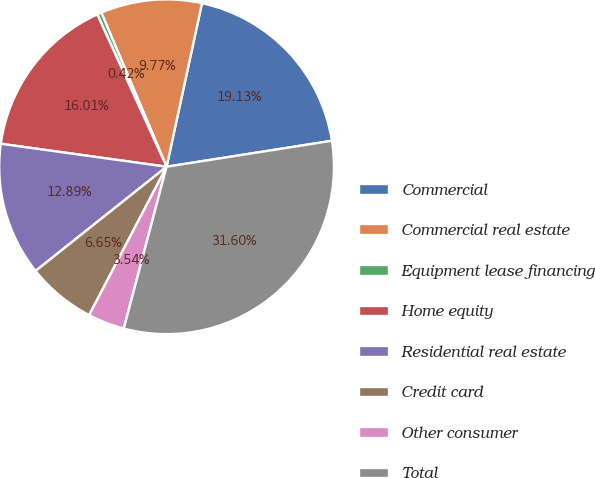Convert chart to OTSL. <chart><loc_0><loc_0><loc_500><loc_500><pie_chart><fcel>Commercial<fcel>Commercial real estate<fcel>Equipment lease financing<fcel>Home equity<fcel>Residential real estate<fcel>Credit card<fcel>Other consumer<fcel>Total<nl><fcel>19.13%<fcel>9.77%<fcel>0.42%<fcel>16.01%<fcel>12.89%<fcel>6.65%<fcel>3.54%<fcel>31.6%<nl></chart> 